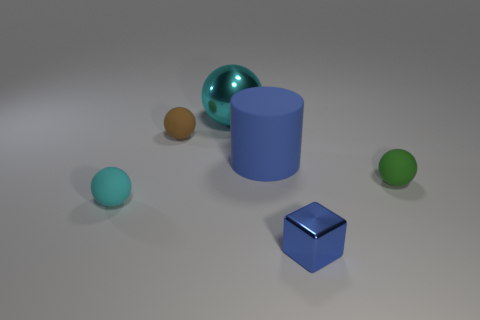Add 4 yellow rubber blocks. How many objects exist? 10 Subtract all cubes. How many objects are left? 5 Subtract all tiny cyan rubber objects. Subtract all cyan shiny things. How many objects are left? 4 Add 1 blue rubber objects. How many blue rubber objects are left? 2 Add 4 red rubber cylinders. How many red rubber cylinders exist? 4 Subtract 0 gray spheres. How many objects are left? 6 